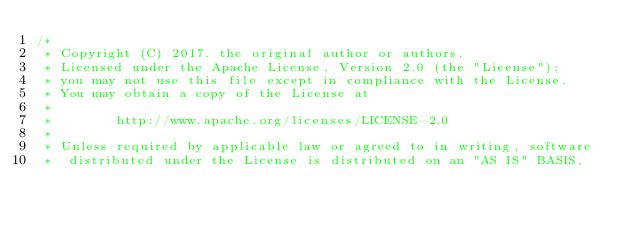<code> <loc_0><loc_0><loc_500><loc_500><_Java_>/*
 * Copyright (C) 2017. the original author or authors.
 * Licensed under the Apache License, Version 2.0 (the "License");
 * you may not use this file except in compliance with the License.
 * You may obtain a copy of the License at
 *
 *        http://www.apache.org/licenses/LICENSE-2.0
 *
 * Unless required by applicable law or agreed to in writing, software
 *  distributed under the License is distributed on an "AS IS" BASIS,</code> 